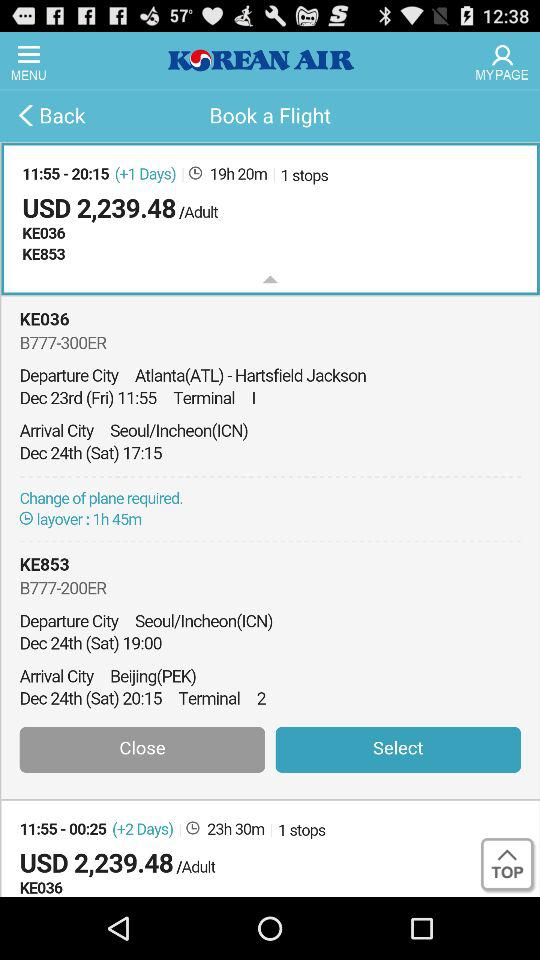Why are flight schedules changed? Flight schedules are changed due to the Pilots Union Strike. 